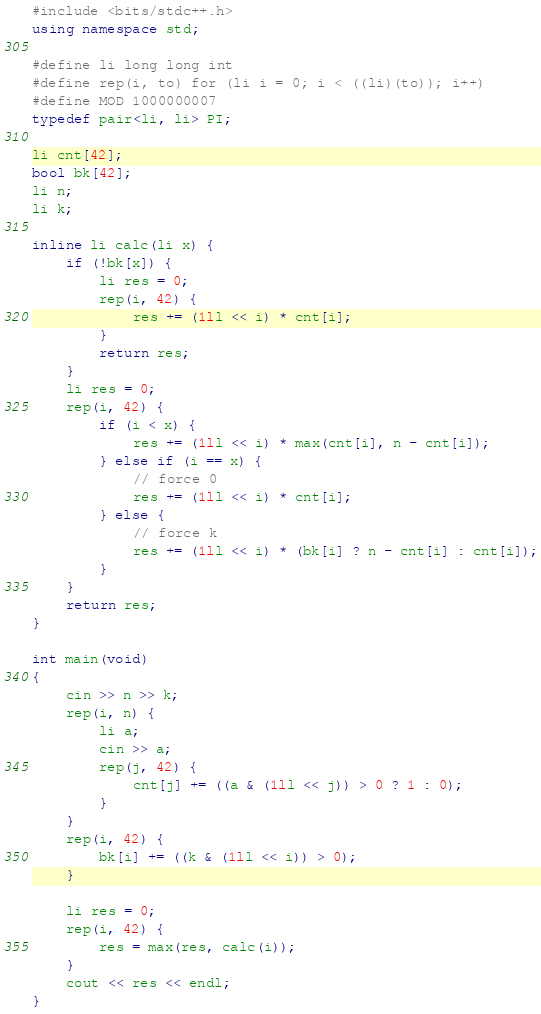<code> <loc_0><loc_0><loc_500><loc_500><_C++_>#include <bits/stdc++.h>
using namespace std;

#define li long long int
#define rep(i, to) for (li i = 0; i < ((li)(to)); i++)
#define MOD 1000000007
typedef pair<li, li> PI;

li cnt[42];
bool bk[42];
li n;
li k;

inline li calc(li x) {
	if (!bk[x]) {
		li res = 0;
		rep(i, 42) {
			res += (1ll << i) * cnt[i];
		}
		return res;
	}
	li res = 0;
	rep(i, 42) {
		if (i < x) {
			res += (1ll << i) * max(cnt[i], n - cnt[i]);
		} else if (i == x) {
			// force 0
			res += (1ll << i) * cnt[i];
		} else {
			// force k
			res += (1ll << i) * (bk[i] ? n - cnt[i] : cnt[i]);
		}
	}
	return res;
}

int main(void)
{
	cin >> n >> k;
	rep(i, n) {
		li a;
		cin >> a;
		rep(j, 42) {
			cnt[j] += ((a & (1ll << j)) > 0 ? 1 : 0);
		}
	}
	rep(i, 42) {
		bk[i] += ((k & (1ll << i)) > 0);
	}

	li res = 0;
	rep(i, 42) {
		res = max(res, calc(i));
	}
	cout << res << endl;
}</code> 